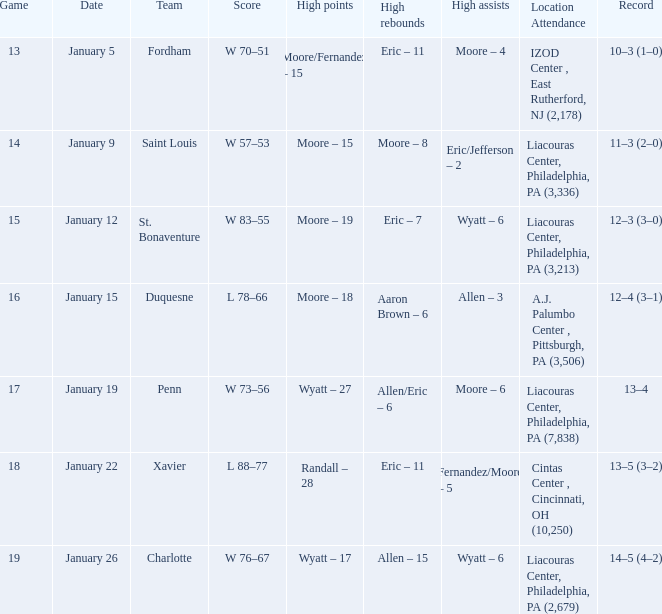What team was Temple playing on January 19? Penn. 